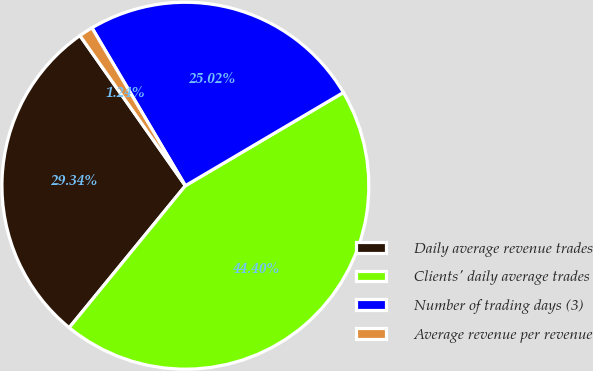<chart> <loc_0><loc_0><loc_500><loc_500><pie_chart><fcel>Daily average revenue trades<fcel>Clients' daily average trades<fcel>Number of trading days (3)<fcel>Average revenue per revenue<nl><fcel>29.34%<fcel>44.4%<fcel>25.02%<fcel>1.24%<nl></chart> 